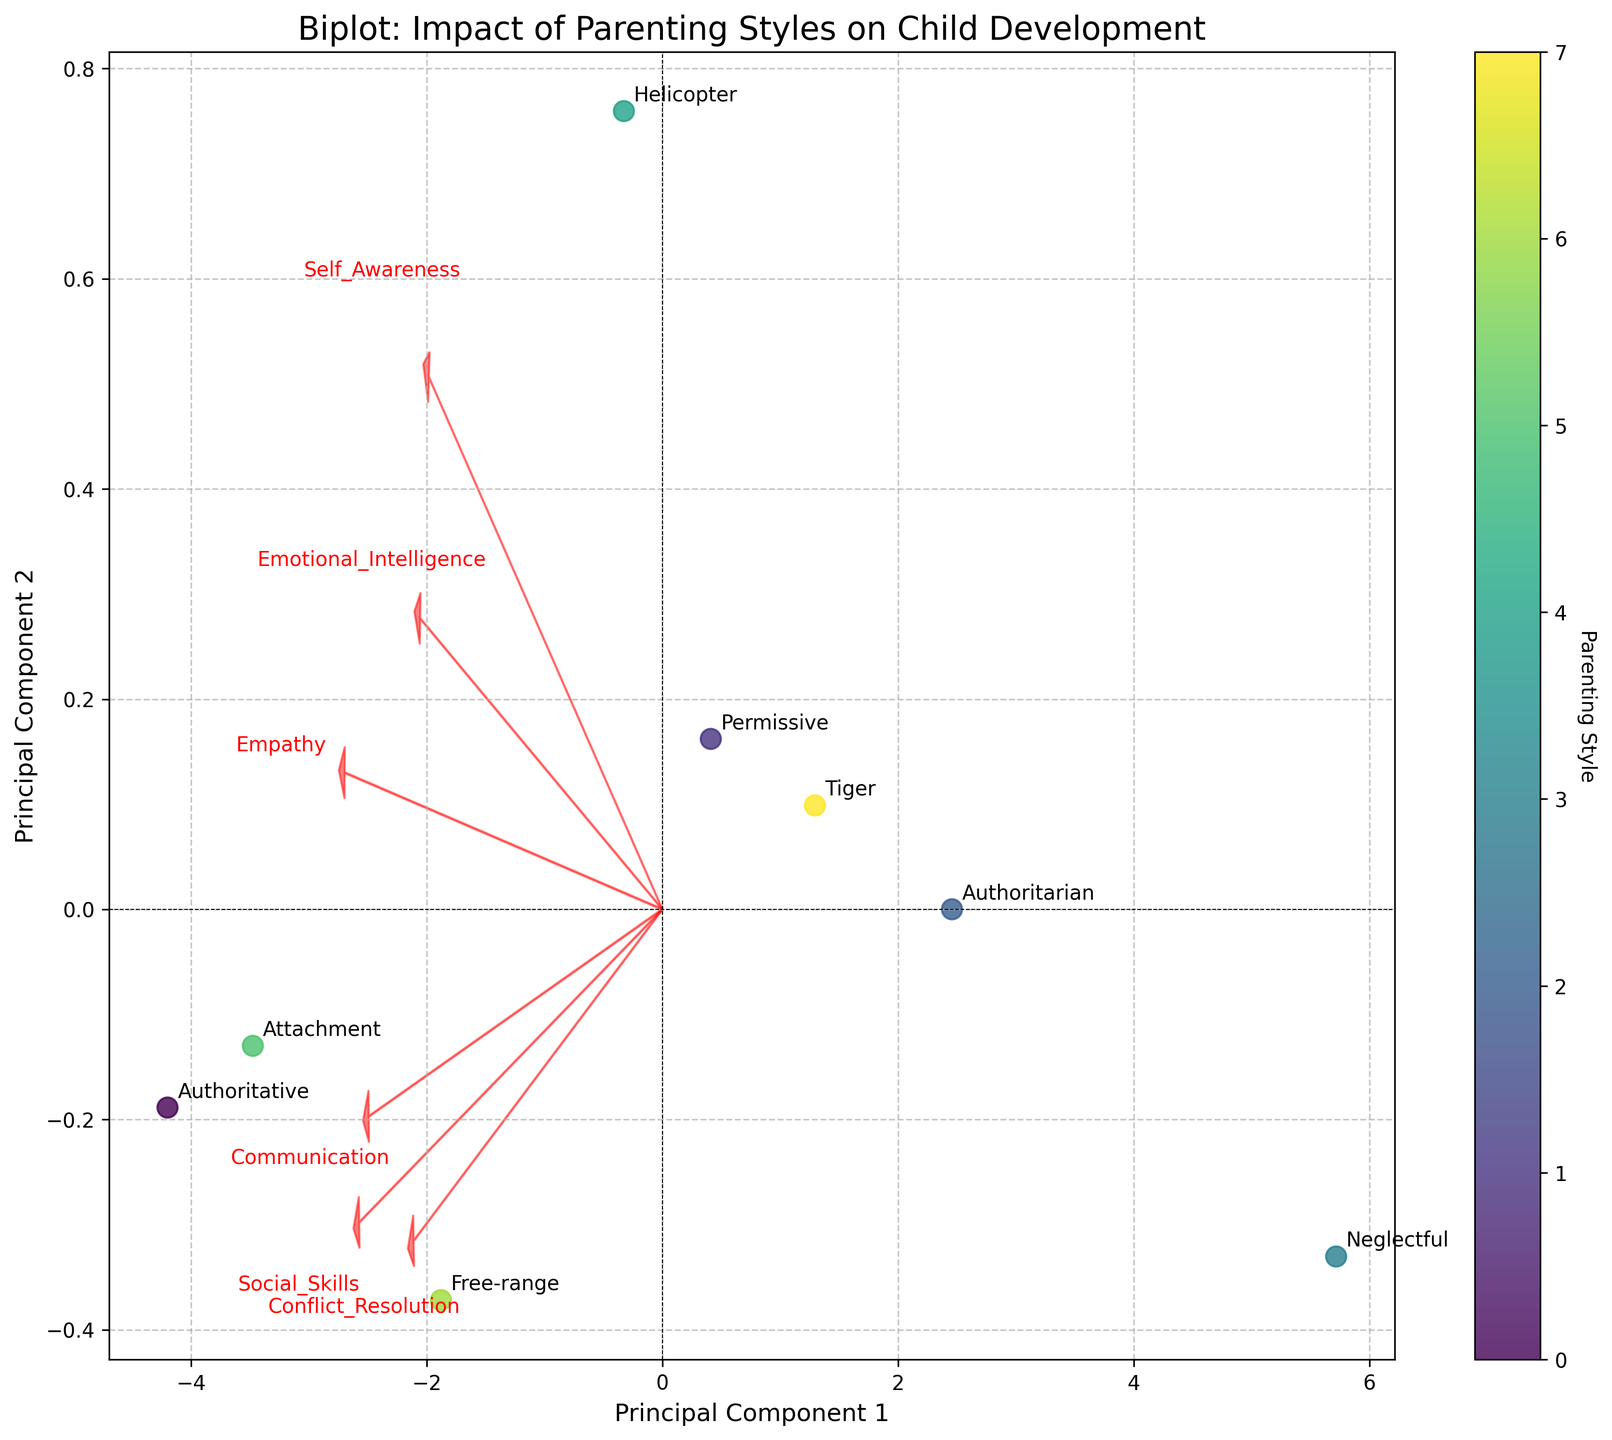How many different parenting styles are shown in the biplot? The biplot has distinct points for each parenting style. By counting the labels or markers, we can determine the number of different styles.
Answer: 8 Which parenting style is associated most closely with high social skills development? In the biplot, the parenting styles closest to the vector representing social skills (moving in the direction of the arrow) indicate high social skills development.
Answer: Authoritative Which dimension (PC1 or PC2) does the "Empathy" vector align more with? By observing the direction of the vector labeled "Empathy," it can be noted if it aligns more with the horizontal axis (PC1) or the vertical axis (PC2).
Answer: PC1 Between Authoritarian and Authoritative parenting styles, which one is shown to have a higher impact on emotional intelligence? Authoritative and Authoritarian data points can be compared based on their projection on the vector labeled "Emotional Intelligence". By noting which point is further along the vector, we can ascertain.
Answer: Authoritative What could be the significance of the data point representing the "Neglectful" parenting style's position on the biplot? The position of the "Neglectful" point can show if it's in regions associated with low or high impacts on various traits by examining its proximity to vectors representing different attributes.
Answer: Low impact on all traits Which parenting style appears to be the least effective in developing self-awareness in children? By examining the projection of each parenting style's point on the "Self Awareness" vector, we can determine which one is the furthest away in the negative direction.
Answer: Neglectful How does the "Tiger" parenting style compare to the "Helicopter" parenting style in terms of communication? By comparing the position of "Tiger" and "Helicopter" relative to the vector marked "Communication," we can see which is closer and thus more positively associated.
Answer: Helicopter Are any parenting styles closely grouped together in the biplot? If so, which ones? By observing the plot for clusters, we can see which data points (representing parenting styles) are positioned near each other, indicating a similarity in their impact dimensions.
Answer: Attachment and Authoritative 